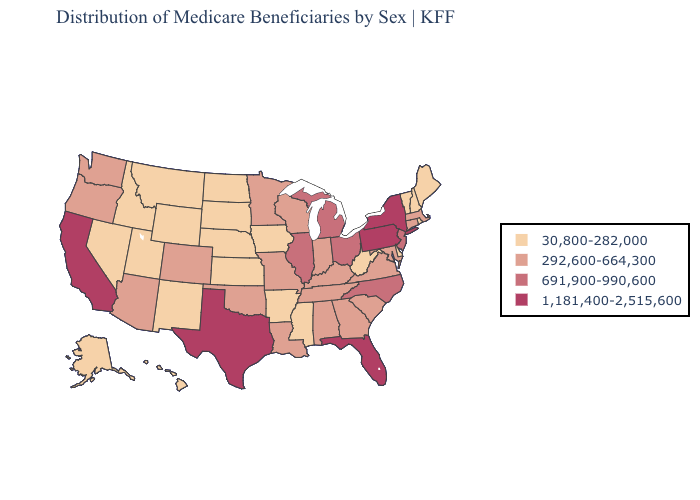Does the first symbol in the legend represent the smallest category?
Short answer required. Yes. Which states hav the highest value in the Northeast?
Be succinct. New York, Pennsylvania. Among the states that border South Dakota , does Minnesota have the highest value?
Keep it brief. Yes. Does New Hampshire have the lowest value in the Northeast?
Answer briefly. Yes. What is the lowest value in the USA?
Answer briefly. 30,800-282,000. What is the highest value in the USA?
Short answer required. 1,181,400-2,515,600. What is the value of Virginia?
Answer briefly. 292,600-664,300. How many symbols are there in the legend?
Short answer required. 4. Does Kansas have the lowest value in the USA?
Quick response, please. Yes. Name the states that have a value in the range 691,900-990,600?
Give a very brief answer. Illinois, Michigan, New Jersey, North Carolina, Ohio. What is the highest value in the West ?
Concise answer only. 1,181,400-2,515,600. Which states have the highest value in the USA?
Be succinct. California, Florida, New York, Pennsylvania, Texas. Name the states that have a value in the range 30,800-282,000?
Write a very short answer. Alaska, Arkansas, Delaware, Hawaii, Idaho, Iowa, Kansas, Maine, Mississippi, Montana, Nebraska, Nevada, New Hampshire, New Mexico, North Dakota, Rhode Island, South Dakota, Utah, Vermont, West Virginia, Wyoming. Which states have the lowest value in the USA?
Write a very short answer. Alaska, Arkansas, Delaware, Hawaii, Idaho, Iowa, Kansas, Maine, Mississippi, Montana, Nebraska, Nevada, New Hampshire, New Mexico, North Dakota, Rhode Island, South Dakota, Utah, Vermont, West Virginia, Wyoming. What is the value of Wyoming?
Quick response, please. 30,800-282,000. 